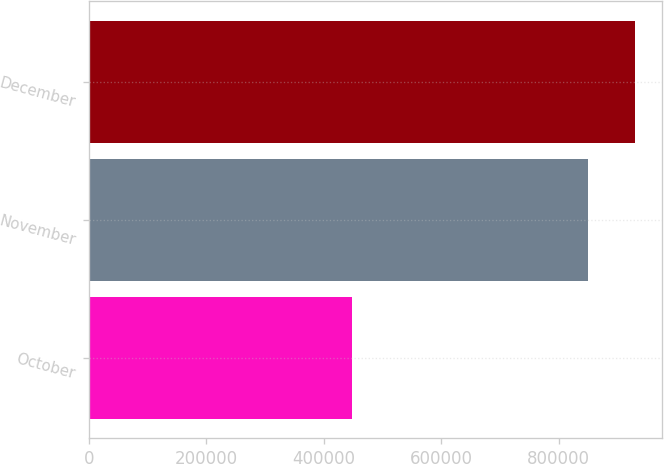Convert chart. <chart><loc_0><loc_0><loc_500><loc_500><bar_chart><fcel>October<fcel>November<fcel>December<nl><fcel>447700<fcel>849200<fcel>929400<nl></chart> 